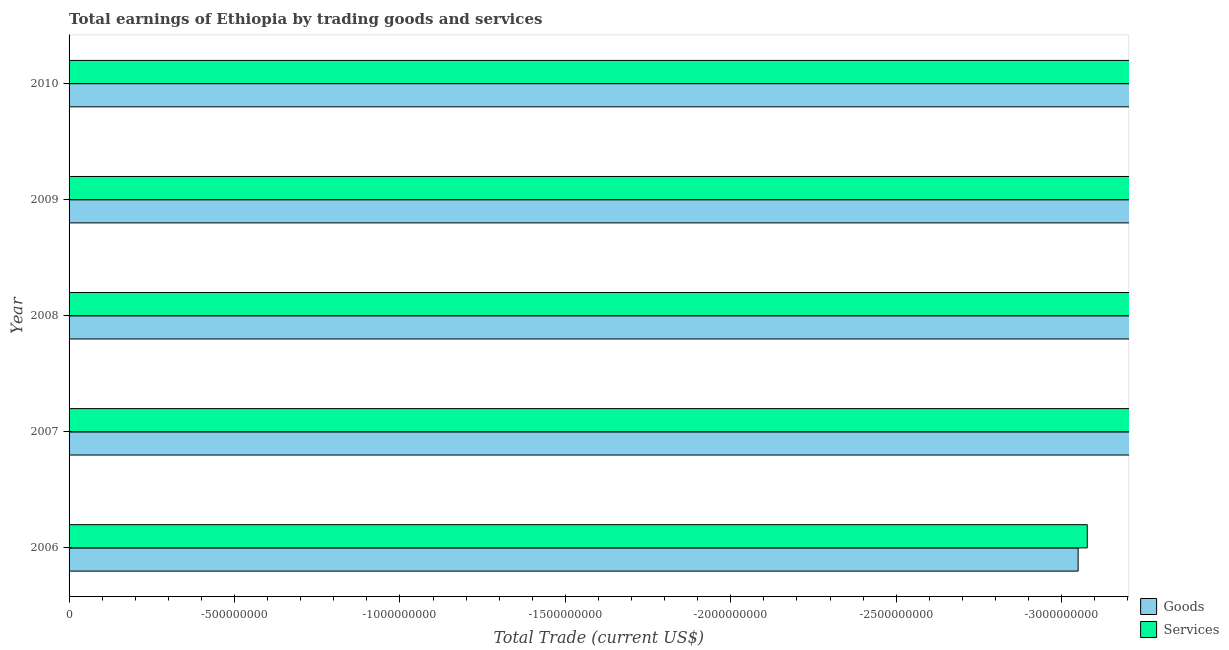What is the label of the 5th group of bars from the top?
Ensure brevity in your answer.  2006. In how many cases, is the number of bars for a given year not equal to the number of legend labels?
Offer a terse response. 5. What is the average amount earned by trading goods per year?
Provide a succinct answer. 0. In how many years, is the amount earned by trading goods greater than -200000000 US$?
Your answer should be compact. 0. Does the graph contain any zero values?
Give a very brief answer. Yes. Where does the legend appear in the graph?
Your answer should be very brief. Bottom right. How many legend labels are there?
Provide a succinct answer. 2. What is the title of the graph?
Provide a short and direct response. Total earnings of Ethiopia by trading goods and services. What is the label or title of the X-axis?
Give a very brief answer. Total Trade (current US$). What is the Total Trade (current US$) in Goods in 2006?
Ensure brevity in your answer.  0. What is the Total Trade (current US$) of Services in 2006?
Offer a very short reply. 0. What is the Total Trade (current US$) in Goods in 2010?
Provide a short and direct response. 0. What is the average Total Trade (current US$) in Goods per year?
Keep it short and to the point. 0. What is the average Total Trade (current US$) in Services per year?
Offer a very short reply. 0. 